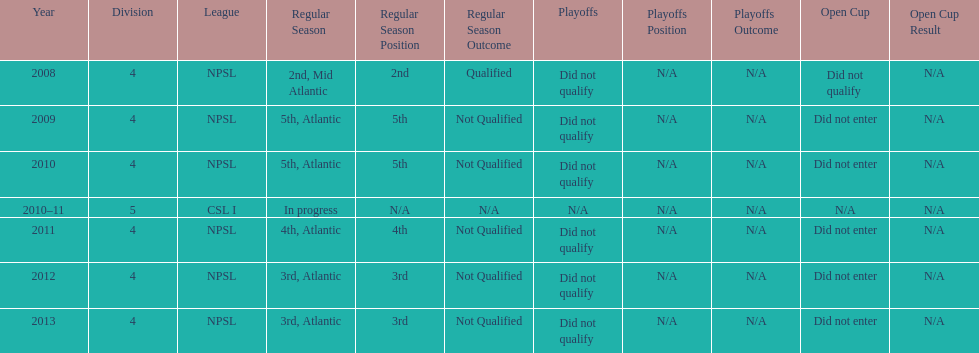What was the last year they came in 3rd place 2013. 